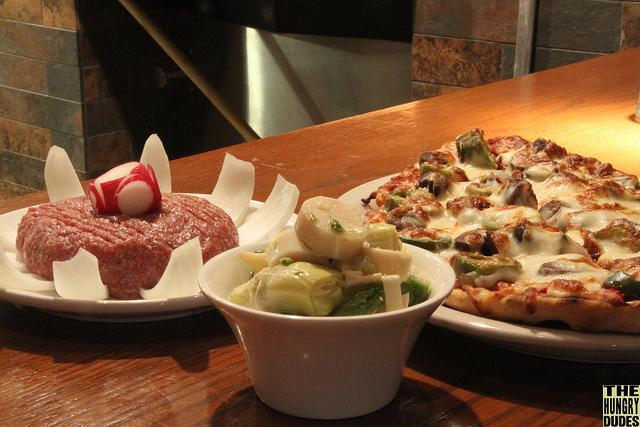What kind of meat is sat to the left of the pizza? beef 